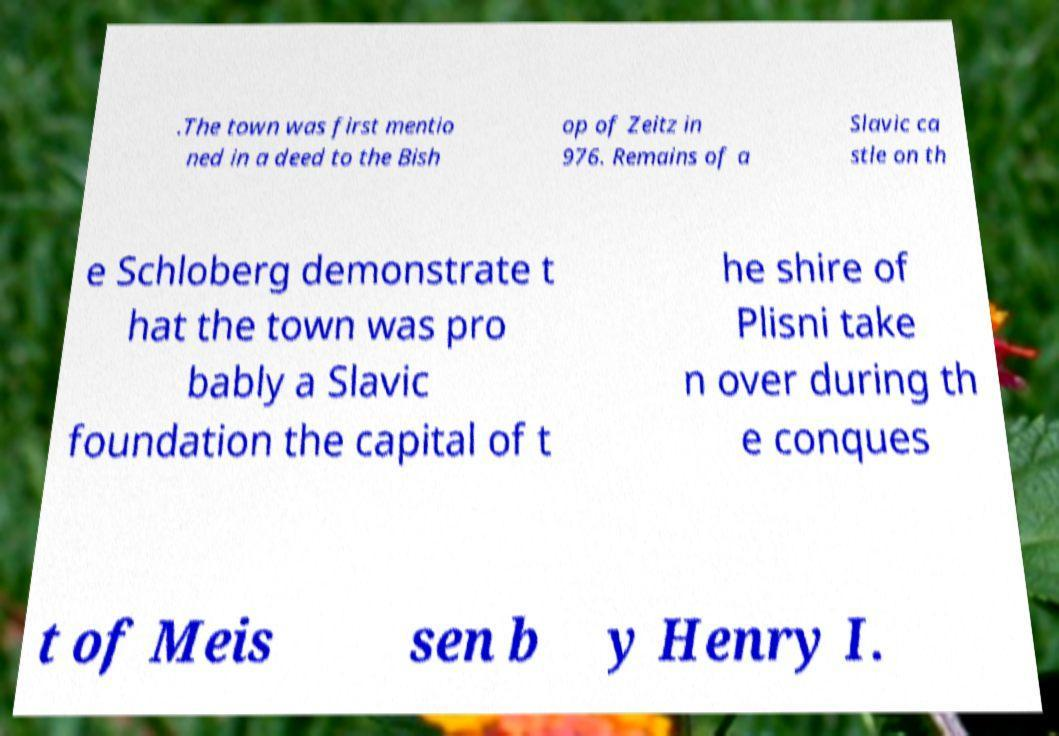Could you extract and type out the text from this image? .The town was first mentio ned in a deed to the Bish op of Zeitz in 976. Remains of a Slavic ca stle on th e Schloberg demonstrate t hat the town was pro bably a Slavic foundation the capital of t he shire of Plisni take n over during th e conques t of Meis sen b y Henry I. 